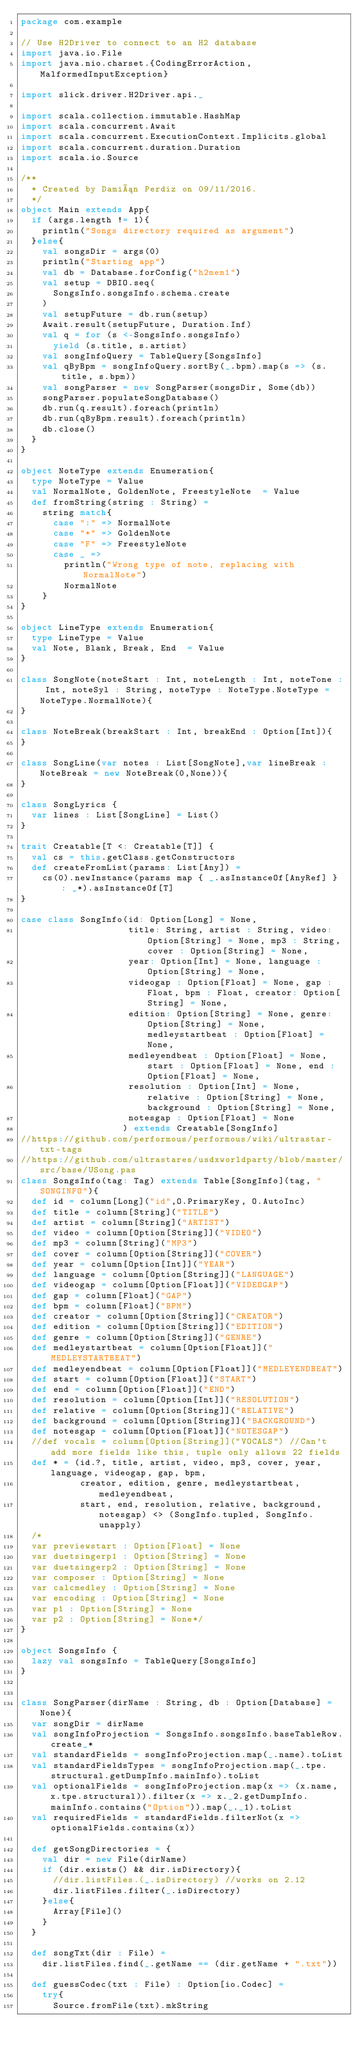<code> <loc_0><loc_0><loc_500><loc_500><_Scala_>package com.example

// Use H2Driver to connect to an H2 database
import java.io.File
import java.nio.charset.{CodingErrorAction, MalformedInputException}

import slick.driver.H2Driver.api._

import scala.collection.immutable.HashMap
import scala.concurrent.Await
import scala.concurrent.ExecutionContext.Implicits.global
import scala.concurrent.duration.Duration
import scala.io.Source

/**
  * Created by Damián Perdiz on 09/11/2016.
  */
object Main extends App{
  if (args.length != 1){
    println("Songs directory required as argument")
  }else{
    val songsDir = args(0)
    println("Starting app")
    val db = Database.forConfig("h2mem1")
    val setup = DBIO.seq(
      SongsInfo.songsInfo.schema.create
    )
    val setupFuture = db.run(setup)
    Await.result(setupFuture, Duration.Inf)
    val q = for (s <-SongsInfo.songsInfo)
      yield (s.title, s.artist)
    val songInfoQuery = TableQuery[SongsInfo]
    val qByBpm = songInfoQuery.sortBy(_.bpm).map(s => (s.title, s.bpm))
    val songParser = new SongParser(songsDir, Some(db))
    songParser.populateSongDatabase()
    db.run(q.result).foreach(println)
    db.run(qByBpm.result).foreach(println)
    db.close()
  }
}

object NoteType extends Enumeration{
  type NoteType = Value
  val NormalNote, GoldenNote, FreestyleNote  = Value
  def fromString(string : String) =
    string match{
      case ":" => NormalNote
      case "*" => GoldenNote
      case "F" => FreestyleNote
      case _ =>
        println("Wrong type of note, replacing with NormalNote")
        NormalNote
    }
}

object LineType extends Enumeration{
  type LineType = Value
  val Note, Blank, Break, End  = Value
}

class SongNote(noteStart : Int, noteLength : Int, noteTone : Int, noteSyl : String, noteType : NoteType.NoteType = NoteType.NormalNote){
}

class NoteBreak(breakStart : Int, breakEnd : Option[Int]){
}

class SongLine(var notes : List[SongNote],var lineBreak : NoteBreak = new NoteBreak(0,None)){
}

class SongLyrics {
  var lines : List[SongLine] = List()
}

trait Creatable[T <: Creatable[T]] {
  val cs = this.getClass.getConstructors
  def createFromList(params: List[Any]) =
    cs(0).newInstance(params map { _.asInstanceOf[AnyRef] } : _*).asInstanceOf[T]
}

case class SongInfo(id: Option[Long] = None,
                    title: String, artist : String, video: Option[String] = None, mp3 : String, cover : Option[String] = None,
                    year: Option[Int] = None, language : Option[String] = None,
                    videogap : Option[Float] = None, gap : Float, bpm : Float, creator: Option[String] = None,
                    edition: Option[String] = None, genre: Option[String] = None, medleystartbeat : Option[Float] = None,
                    medleyendbeat : Option[Float] = None, start : Option[Float] = None, end : Option[Float] = None,
                    resolution : Option[Int] = None, relative : Option[String] = None, background : Option[String] = None,
                    notesgap : Option[Float] = None
                   ) extends Creatable[SongInfo]
//https://github.com/performous/performous/wiki/ultrastar-txt-tags
//https://github.com/ultrastares/usdxworldparty/blob/master/src/base/USong.pas
class SongsInfo(tag: Tag) extends Table[SongInfo](tag, "SONGINFO"){
  def id = column[Long]("id",O.PrimaryKey, O.AutoInc)
  def title = column[String]("TITLE")
  def artist = column[String]("ARTIST")
  def video = column[Option[String]]("VIDEO")
  def mp3 = column[String]("MP3")
  def cover = column[Option[String]]("COVER")
  def year = column[Option[Int]]("YEAR")
  def language = column[Option[String]]("LANGUAGE")
  def videogap = column[Option[Float]]("VIDEOGAP")
  def gap = column[Float]("GAP")
  def bpm = column[Float]("BPM")
  def creator = column[Option[String]]("CREATOR")
  def edition = column[Option[String]]("EDITION")
  def genre = column[Option[String]]("GENRE")
  def medleystartbeat = column[Option[Float]]("MEDLEYSTARTBEAT")
  def medleyendbeat = column[Option[Float]]("MEDLEYENDBEAT")
  def start = column[Option[Float]]("START")
  def end = column[Option[Float]]("END")
  def resolution = column[Option[Int]]("RESOLUTION")
  def relative = column[Option[String]]("RELATIVE")
  def background = column[Option[String]]("BACKGROUND")
  def notesgap = column[Option[Float]]("NOTESGAP")
  //def vocals = column[Option[String]]("VOCALS") //Can't add more fields like this, tuple only allows 22 fields
  def * = (id.?, title, artist, video, mp3, cover, year, language, videogap, gap, bpm,
           creator, edition, genre, medleystartbeat, medleyendbeat,
           start, end, resolution, relative, background, notesgap) <> (SongInfo.tupled, SongInfo.unapply)
  /*
  var previewstart : Option[Float] = None
  var duetsingerp1 : Option[String] = None
  var duetsingerp2 : Option[String] = None
  var composer : Option[String] = None
  var calcmedley : Option[String] = None
  var encoding : Option[String] = None
  var p1 : Option[String] = None
  var p2 : Option[String] = None*/
}

object SongsInfo {
  lazy val songsInfo = TableQuery[SongsInfo]
}


class SongParser(dirName : String, db : Option[Database] = None){
  var songDir = dirName
  val songInfoProjection = SongsInfo.songsInfo.baseTableRow.create_*
  val standardFields = songInfoProjection.map(_.name).toList
  val standardFieldsTypes = songInfoProjection.map(_.tpe.structural.getDumpInfo.mainInfo).toList
  val optionalFields = songInfoProjection.map(x => (x.name, x.tpe.structural)).filter(x => x._2.getDumpInfo.mainInfo.contains("Option")).map(_._1).toList
  val requiredFields = standardFields.filterNot(x => optionalFields.contains(x))

  def getSongDirectories = {
    val dir = new File(dirName)
    if (dir.exists() && dir.isDirectory){
      //dir.listFiles.(_.isDirectory) //works on 2.12
      dir.listFiles.filter(_.isDirectory)
    }else{
      Array[File]()
    }
  }

  def songTxt(dir : File) =
    dir.listFiles.find(_.getName == (dir.getName + ".txt"))

  def guessCodec(txt : File) : Option[io.Codec] =
    try{
      Source.fromFile(txt).mkString</code> 